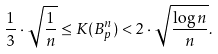<formula> <loc_0><loc_0><loc_500><loc_500>\frac { 1 } { 3 } \cdot \sqrt { \frac { 1 } { n } } \leq K ( B ^ { n } _ { p } ) < 2 \cdot \sqrt { \frac { \log n } { n } } .</formula> 